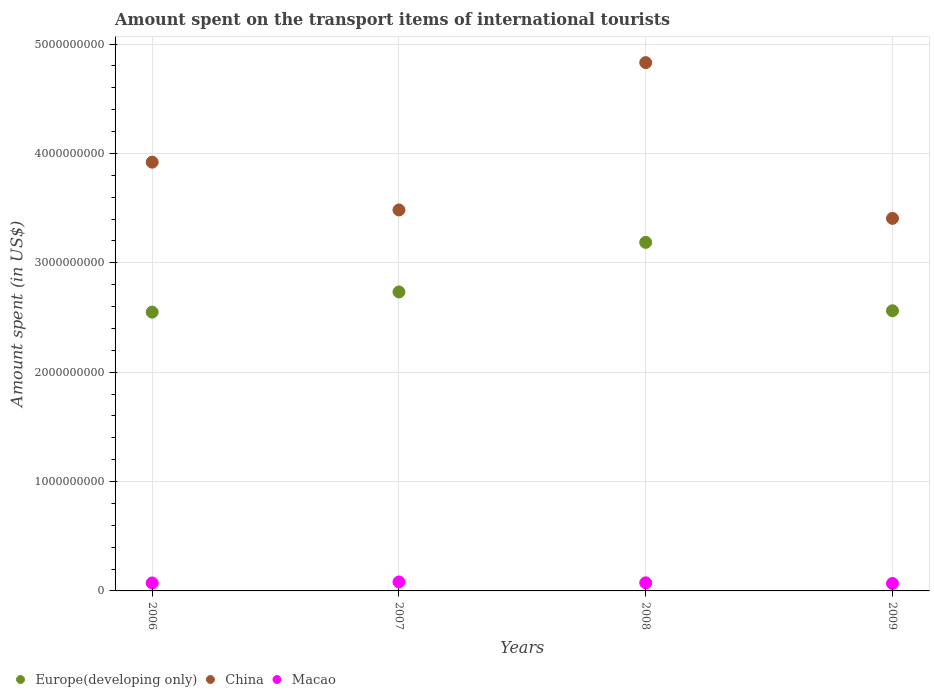Is the number of dotlines equal to the number of legend labels?
Keep it short and to the point. Yes. What is the amount spent on the transport items of international tourists in China in 2008?
Offer a terse response. 4.83e+09. Across all years, what is the maximum amount spent on the transport items of international tourists in Macao?
Provide a short and direct response. 8.20e+07. Across all years, what is the minimum amount spent on the transport items of international tourists in China?
Ensure brevity in your answer.  3.41e+09. In which year was the amount spent on the transport items of international tourists in Macao maximum?
Your answer should be compact. 2007. In which year was the amount spent on the transport items of international tourists in China minimum?
Offer a terse response. 2009. What is the total amount spent on the transport items of international tourists in China in the graph?
Keep it short and to the point. 1.56e+1. What is the difference between the amount spent on the transport items of international tourists in China in 2008 and that in 2009?
Provide a short and direct response. 1.42e+09. What is the difference between the amount spent on the transport items of international tourists in Macao in 2008 and the amount spent on the transport items of international tourists in China in 2009?
Give a very brief answer. -3.33e+09. What is the average amount spent on the transport items of international tourists in Europe(developing only) per year?
Your answer should be very brief. 2.76e+09. In the year 2006, what is the difference between the amount spent on the transport items of international tourists in Macao and amount spent on the transport items of international tourists in China?
Give a very brief answer. -3.85e+09. In how many years, is the amount spent on the transport items of international tourists in Europe(developing only) greater than 3800000000 US$?
Your answer should be compact. 0. What is the ratio of the amount spent on the transport items of international tourists in China in 2006 to that in 2008?
Ensure brevity in your answer.  0.81. What is the difference between the highest and the second highest amount spent on the transport items of international tourists in China?
Your response must be concise. 9.10e+08. What is the difference between the highest and the lowest amount spent on the transport items of international tourists in Europe(developing only)?
Offer a terse response. 6.38e+08. In how many years, is the amount spent on the transport items of international tourists in Macao greater than the average amount spent on the transport items of international tourists in Macao taken over all years?
Offer a very short reply. 1. Is the sum of the amount spent on the transport items of international tourists in China in 2006 and 2007 greater than the maximum amount spent on the transport items of international tourists in Europe(developing only) across all years?
Offer a very short reply. Yes. Is it the case that in every year, the sum of the amount spent on the transport items of international tourists in China and amount spent on the transport items of international tourists in Europe(developing only)  is greater than the amount spent on the transport items of international tourists in Macao?
Provide a short and direct response. Yes. Does the amount spent on the transport items of international tourists in China monotonically increase over the years?
Ensure brevity in your answer.  No. How many dotlines are there?
Ensure brevity in your answer.  3. How many years are there in the graph?
Give a very brief answer. 4. What is the difference between two consecutive major ticks on the Y-axis?
Offer a terse response. 1.00e+09. Are the values on the major ticks of Y-axis written in scientific E-notation?
Give a very brief answer. No. Does the graph contain grids?
Offer a very short reply. Yes. How many legend labels are there?
Ensure brevity in your answer.  3. How are the legend labels stacked?
Your answer should be very brief. Horizontal. What is the title of the graph?
Give a very brief answer. Amount spent on the transport items of international tourists. What is the label or title of the Y-axis?
Your answer should be very brief. Amount spent (in US$). What is the Amount spent (in US$) of Europe(developing only) in 2006?
Your response must be concise. 2.55e+09. What is the Amount spent (in US$) of China in 2006?
Provide a succinct answer. 3.92e+09. What is the Amount spent (in US$) in Macao in 2006?
Provide a short and direct response. 7.30e+07. What is the Amount spent (in US$) of Europe(developing only) in 2007?
Offer a very short reply. 2.73e+09. What is the Amount spent (in US$) in China in 2007?
Keep it short and to the point. 3.48e+09. What is the Amount spent (in US$) in Macao in 2007?
Offer a very short reply. 8.20e+07. What is the Amount spent (in US$) in Europe(developing only) in 2008?
Offer a terse response. 3.19e+09. What is the Amount spent (in US$) in China in 2008?
Give a very brief answer. 4.83e+09. What is the Amount spent (in US$) of Macao in 2008?
Provide a short and direct response. 7.40e+07. What is the Amount spent (in US$) of Europe(developing only) in 2009?
Offer a terse response. 2.56e+09. What is the Amount spent (in US$) of China in 2009?
Offer a terse response. 3.41e+09. What is the Amount spent (in US$) of Macao in 2009?
Your answer should be very brief. 6.80e+07. Across all years, what is the maximum Amount spent (in US$) in Europe(developing only)?
Ensure brevity in your answer.  3.19e+09. Across all years, what is the maximum Amount spent (in US$) in China?
Provide a short and direct response. 4.83e+09. Across all years, what is the maximum Amount spent (in US$) in Macao?
Offer a very short reply. 8.20e+07. Across all years, what is the minimum Amount spent (in US$) in Europe(developing only)?
Your answer should be very brief. 2.55e+09. Across all years, what is the minimum Amount spent (in US$) in China?
Provide a short and direct response. 3.41e+09. Across all years, what is the minimum Amount spent (in US$) of Macao?
Make the answer very short. 6.80e+07. What is the total Amount spent (in US$) of Europe(developing only) in the graph?
Provide a succinct answer. 1.10e+1. What is the total Amount spent (in US$) in China in the graph?
Ensure brevity in your answer.  1.56e+1. What is the total Amount spent (in US$) of Macao in the graph?
Provide a succinct answer. 2.97e+08. What is the difference between the Amount spent (in US$) in Europe(developing only) in 2006 and that in 2007?
Your answer should be very brief. -1.85e+08. What is the difference between the Amount spent (in US$) of China in 2006 and that in 2007?
Provide a succinct answer. 4.37e+08. What is the difference between the Amount spent (in US$) in Macao in 2006 and that in 2007?
Make the answer very short. -9.00e+06. What is the difference between the Amount spent (in US$) of Europe(developing only) in 2006 and that in 2008?
Provide a succinct answer. -6.38e+08. What is the difference between the Amount spent (in US$) of China in 2006 and that in 2008?
Keep it short and to the point. -9.10e+08. What is the difference between the Amount spent (in US$) in Macao in 2006 and that in 2008?
Give a very brief answer. -1.00e+06. What is the difference between the Amount spent (in US$) in Europe(developing only) in 2006 and that in 2009?
Offer a very short reply. -1.24e+07. What is the difference between the Amount spent (in US$) in China in 2006 and that in 2009?
Keep it short and to the point. 5.14e+08. What is the difference between the Amount spent (in US$) in Macao in 2006 and that in 2009?
Offer a very short reply. 5.00e+06. What is the difference between the Amount spent (in US$) in Europe(developing only) in 2007 and that in 2008?
Your answer should be very brief. -4.53e+08. What is the difference between the Amount spent (in US$) in China in 2007 and that in 2008?
Your answer should be compact. -1.35e+09. What is the difference between the Amount spent (in US$) in Macao in 2007 and that in 2008?
Ensure brevity in your answer.  8.00e+06. What is the difference between the Amount spent (in US$) of Europe(developing only) in 2007 and that in 2009?
Your response must be concise. 1.72e+08. What is the difference between the Amount spent (in US$) in China in 2007 and that in 2009?
Your answer should be compact. 7.70e+07. What is the difference between the Amount spent (in US$) in Macao in 2007 and that in 2009?
Offer a terse response. 1.40e+07. What is the difference between the Amount spent (in US$) in Europe(developing only) in 2008 and that in 2009?
Make the answer very short. 6.25e+08. What is the difference between the Amount spent (in US$) in China in 2008 and that in 2009?
Offer a terse response. 1.42e+09. What is the difference between the Amount spent (in US$) of Macao in 2008 and that in 2009?
Your response must be concise. 6.00e+06. What is the difference between the Amount spent (in US$) in Europe(developing only) in 2006 and the Amount spent (in US$) in China in 2007?
Provide a succinct answer. -9.34e+08. What is the difference between the Amount spent (in US$) of Europe(developing only) in 2006 and the Amount spent (in US$) of Macao in 2007?
Offer a very short reply. 2.47e+09. What is the difference between the Amount spent (in US$) of China in 2006 and the Amount spent (in US$) of Macao in 2007?
Provide a succinct answer. 3.84e+09. What is the difference between the Amount spent (in US$) of Europe(developing only) in 2006 and the Amount spent (in US$) of China in 2008?
Offer a terse response. -2.28e+09. What is the difference between the Amount spent (in US$) of Europe(developing only) in 2006 and the Amount spent (in US$) of Macao in 2008?
Your answer should be compact. 2.47e+09. What is the difference between the Amount spent (in US$) in China in 2006 and the Amount spent (in US$) in Macao in 2008?
Your answer should be very brief. 3.85e+09. What is the difference between the Amount spent (in US$) in Europe(developing only) in 2006 and the Amount spent (in US$) in China in 2009?
Your answer should be very brief. -8.57e+08. What is the difference between the Amount spent (in US$) of Europe(developing only) in 2006 and the Amount spent (in US$) of Macao in 2009?
Offer a very short reply. 2.48e+09. What is the difference between the Amount spent (in US$) in China in 2006 and the Amount spent (in US$) in Macao in 2009?
Give a very brief answer. 3.85e+09. What is the difference between the Amount spent (in US$) in Europe(developing only) in 2007 and the Amount spent (in US$) in China in 2008?
Ensure brevity in your answer.  -2.10e+09. What is the difference between the Amount spent (in US$) in Europe(developing only) in 2007 and the Amount spent (in US$) in Macao in 2008?
Your answer should be compact. 2.66e+09. What is the difference between the Amount spent (in US$) in China in 2007 and the Amount spent (in US$) in Macao in 2008?
Your answer should be very brief. 3.41e+09. What is the difference between the Amount spent (in US$) of Europe(developing only) in 2007 and the Amount spent (in US$) of China in 2009?
Give a very brief answer. -6.73e+08. What is the difference between the Amount spent (in US$) of Europe(developing only) in 2007 and the Amount spent (in US$) of Macao in 2009?
Keep it short and to the point. 2.67e+09. What is the difference between the Amount spent (in US$) of China in 2007 and the Amount spent (in US$) of Macao in 2009?
Keep it short and to the point. 3.42e+09. What is the difference between the Amount spent (in US$) of Europe(developing only) in 2008 and the Amount spent (in US$) of China in 2009?
Your answer should be compact. -2.19e+08. What is the difference between the Amount spent (in US$) of Europe(developing only) in 2008 and the Amount spent (in US$) of Macao in 2009?
Provide a short and direct response. 3.12e+09. What is the difference between the Amount spent (in US$) of China in 2008 and the Amount spent (in US$) of Macao in 2009?
Give a very brief answer. 4.76e+09. What is the average Amount spent (in US$) of Europe(developing only) per year?
Make the answer very short. 2.76e+09. What is the average Amount spent (in US$) of China per year?
Your response must be concise. 3.91e+09. What is the average Amount spent (in US$) of Macao per year?
Your answer should be compact. 7.42e+07. In the year 2006, what is the difference between the Amount spent (in US$) of Europe(developing only) and Amount spent (in US$) of China?
Your answer should be very brief. -1.37e+09. In the year 2006, what is the difference between the Amount spent (in US$) of Europe(developing only) and Amount spent (in US$) of Macao?
Offer a very short reply. 2.48e+09. In the year 2006, what is the difference between the Amount spent (in US$) in China and Amount spent (in US$) in Macao?
Offer a terse response. 3.85e+09. In the year 2007, what is the difference between the Amount spent (in US$) of Europe(developing only) and Amount spent (in US$) of China?
Provide a succinct answer. -7.50e+08. In the year 2007, what is the difference between the Amount spent (in US$) of Europe(developing only) and Amount spent (in US$) of Macao?
Provide a short and direct response. 2.65e+09. In the year 2007, what is the difference between the Amount spent (in US$) in China and Amount spent (in US$) in Macao?
Provide a succinct answer. 3.40e+09. In the year 2008, what is the difference between the Amount spent (in US$) of Europe(developing only) and Amount spent (in US$) of China?
Your response must be concise. -1.64e+09. In the year 2008, what is the difference between the Amount spent (in US$) of Europe(developing only) and Amount spent (in US$) of Macao?
Give a very brief answer. 3.11e+09. In the year 2008, what is the difference between the Amount spent (in US$) of China and Amount spent (in US$) of Macao?
Provide a short and direct response. 4.76e+09. In the year 2009, what is the difference between the Amount spent (in US$) of Europe(developing only) and Amount spent (in US$) of China?
Give a very brief answer. -8.45e+08. In the year 2009, what is the difference between the Amount spent (in US$) of Europe(developing only) and Amount spent (in US$) of Macao?
Provide a succinct answer. 2.49e+09. In the year 2009, what is the difference between the Amount spent (in US$) in China and Amount spent (in US$) in Macao?
Provide a short and direct response. 3.34e+09. What is the ratio of the Amount spent (in US$) in Europe(developing only) in 2006 to that in 2007?
Keep it short and to the point. 0.93. What is the ratio of the Amount spent (in US$) in China in 2006 to that in 2007?
Your answer should be very brief. 1.13. What is the ratio of the Amount spent (in US$) of Macao in 2006 to that in 2007?
Make the answer very short. 0.89. What is the ratio of the Amount spent (in US$) of Europe(developing only) in 2006 to that in 2008?
Your answer should be compact. 0.8. What is the ratio of the Amount spent (in US$) of China in 2006 to that in 2008?
Provide a succinct answer. 0.81. What is the ratio of the Amount spent (in US$) of Macao in 2006 to that in 2008?
Give a very brief answer. 0.99. What is the ratio of the Amount spent (in US$) in China in 2006 to that in 2009?
Your response must be concise. 1.15. What is the ratio of the Amount spent (in US$) of Macao in 2006 to that in 2009?
Your answer should be compact. 1.07. What is the ratio of the Amount spent (in US$) in Europe(developing only) in 2007 to that in 2008?
Offer a very short reply. 0.86. What is the ratio of the Amount spent (in US$) in China in 2007 to that in 2008?
Your answer should be compact. 0.72. What is the ratio of the Amount spent (in US$) of Macao in 2007 to that in 2008?
Offer a very short reply. 1.11. What is the ratio of the Amount spent (in US$) of Europe(developing only) in 2007 to that in 2009?
Provide a short and direct response. 1.07. What is the ratio of the Amount spent (in US$) of China in 2007 to that in 2009?
Make the answer very short. 1.02. What is the ratio of the Amount spent (in US$) of Macao in 2007 to that in 2009?
Ensure brevity in your answer.  1.21. What is the ratio of the Amount spent (in US$) in Europe(developing only) in 2008 to that in 2009?
Make the answer very short. 1.24. What is the ratio of the Amount spent (in US$) of China in 2008 to that in 2009?
Offer a very short reply. 1.42. What is the ratio of the Amount spent (in US$) of Macao in 2008 to that in 2009?
Your answer should be very brief. 1.09. What is the difference between the highest and the second highest Amount spent (in US$) of Europe(developing only)?
Your answer should be very brief. 4.53e+08. What is the difference between the highest and the second highest Amount spent (in US$) of China?
Your answer should be very brief. 9.10e+08. What is the difference between the highest and the lowest Amount spent (in US$) of Europe(developing only)?
Your response must be concise. 6.38e+08. What is the difference between the highest and the lowest Amount spent (in US$) of China?
Give a very brief answer. 1.42e+09. What is the difference between the highest and the lowest Amount spent (in US$) in Macao?
Make the answer very short. 1.40e+07. 